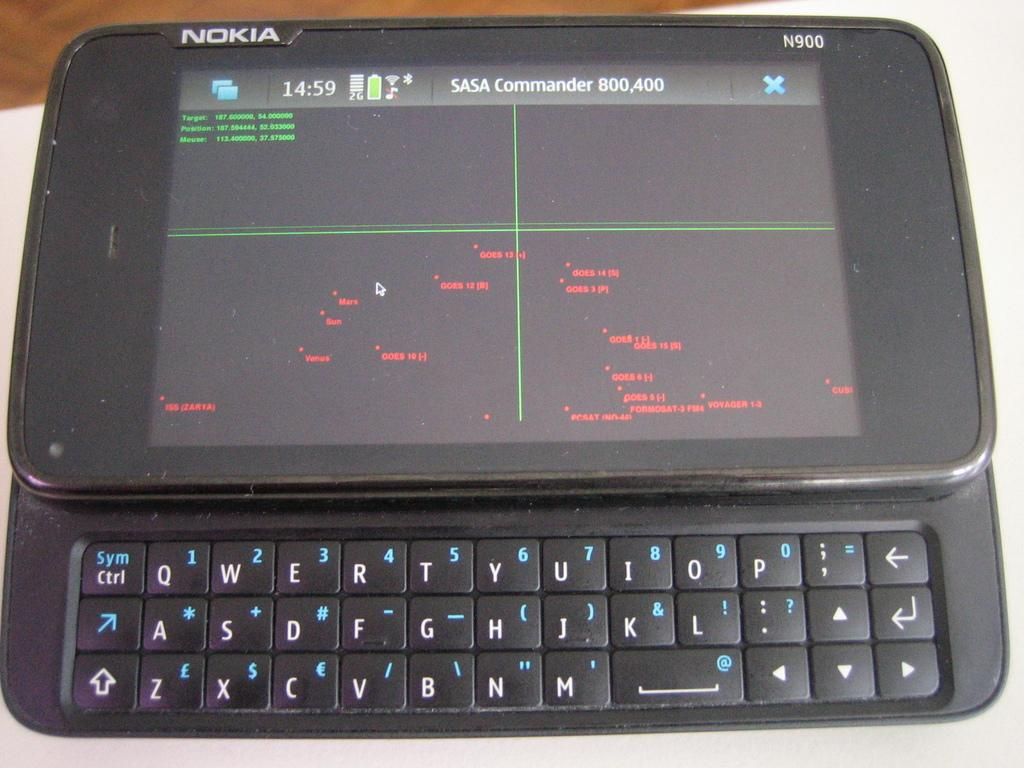What electronic device is present in the picture? There is a mobile phone in the picture. What can be seen on the screen of the mobile phone? Something is displayed on the mobile phone. What part of the mobile phone is visible in the image? The keypad of the mobile phone is visible. What color is the surface on which the mobile phone is placed? The mobile phone is placed on a white color surface. What type of leaf is falling on the stage in the image? There is no leaf or stage present in the image; it features a mobile phone placed on a white surface. 